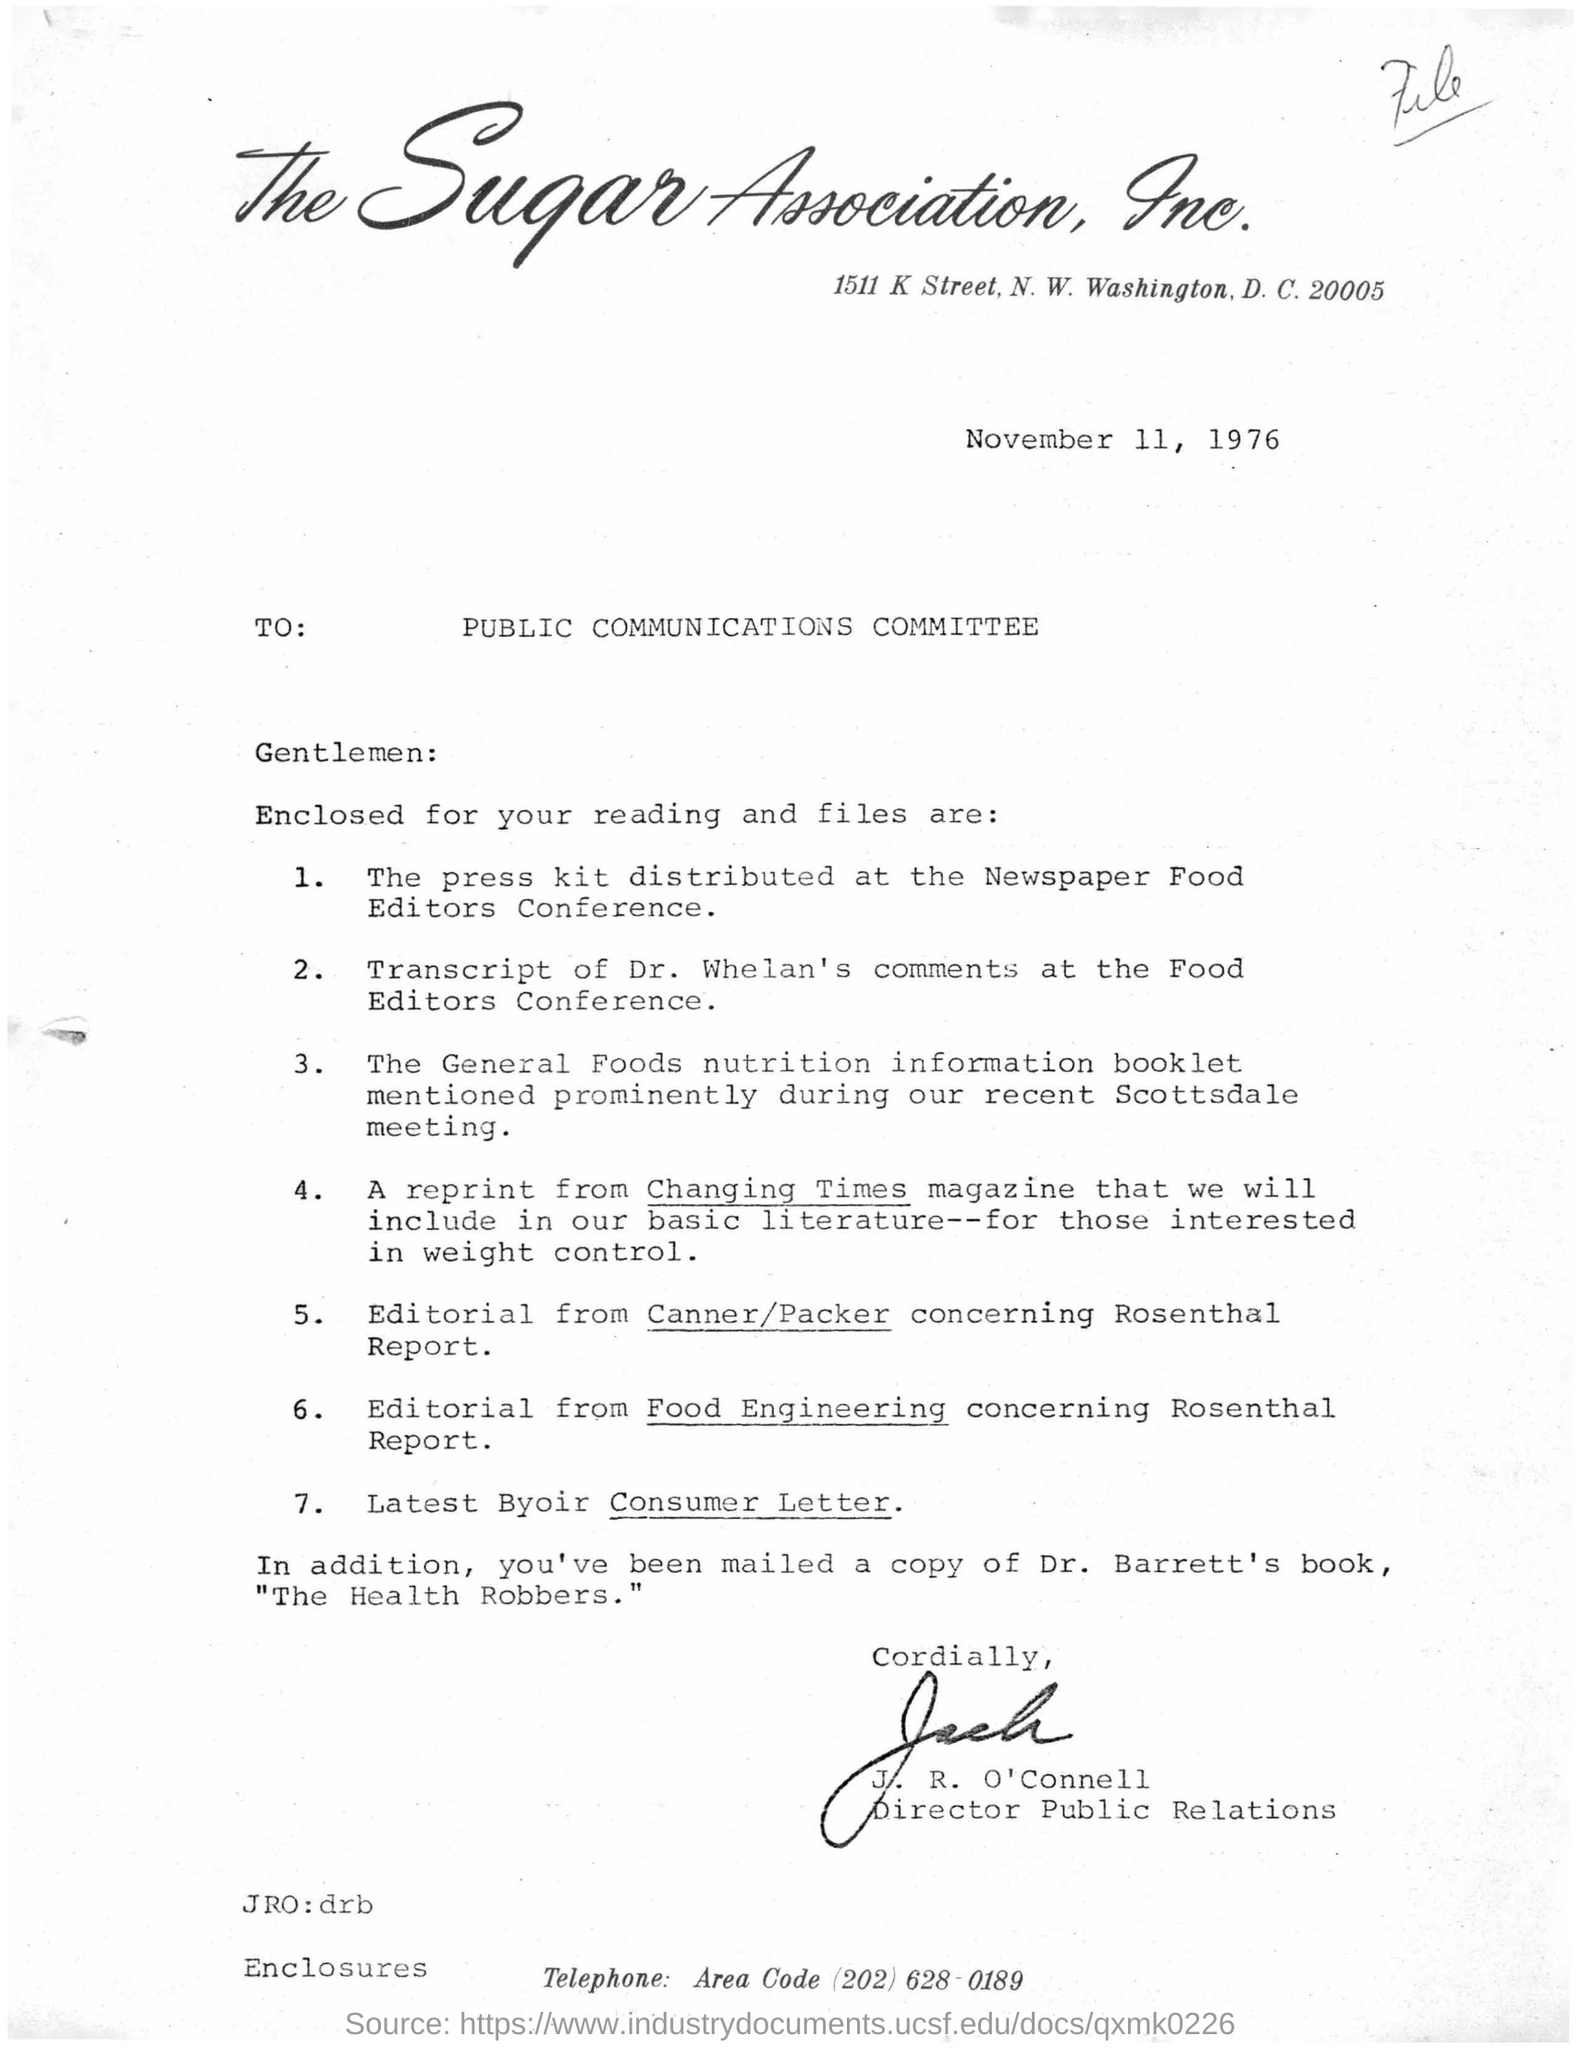List a handful of essential elements in this visual. The address of the Sugar Association, Inc. is 1511 K Street, N.W., Washington, D.C. 20005. On November 11, 1976, a letter was dated. The name of the incorporated company is the Sugar Association. J.R. O'Connell is sending this letter to the Public Communications Committee. A reprint from a magazine that would be included in the basic literature for those interested in weight control, despite changing times, is still relevant today. 